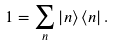Convert formula to latex. <formula><loc_0><loc_0><loc_500><loc_500>1 = \sum _ { n } \left | n \right \rangle \left \langle n \right | .</formula> 